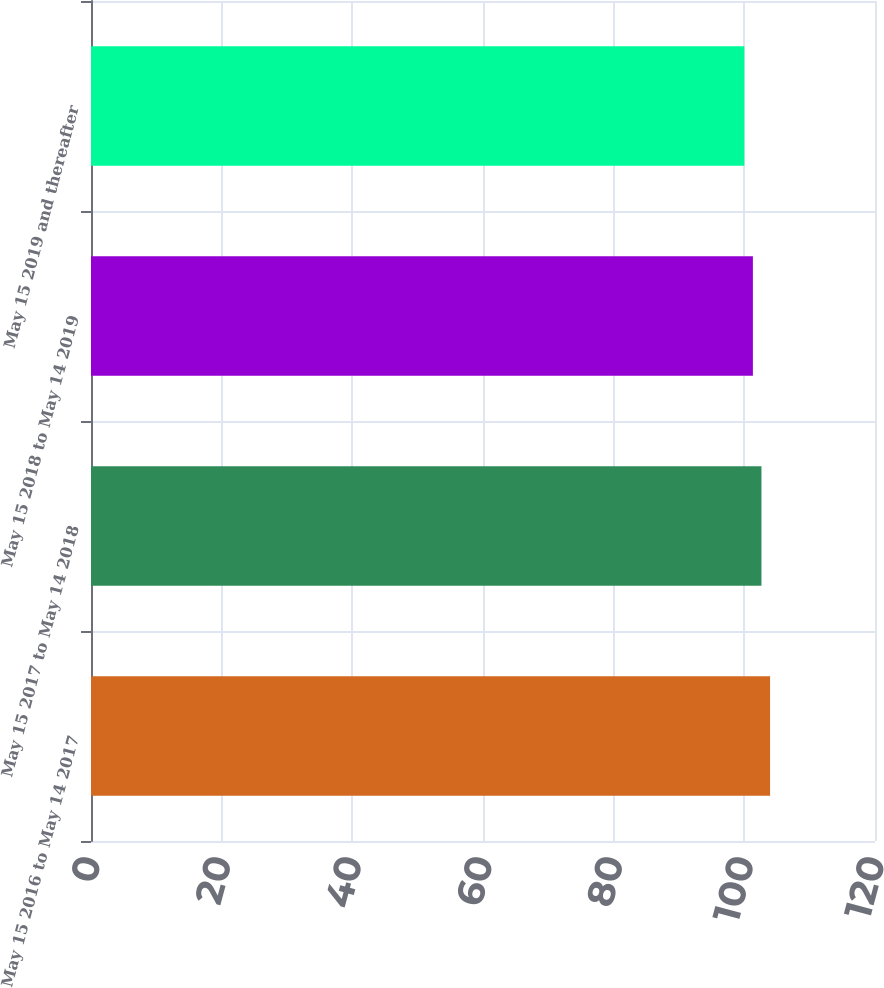Convert chart. <chart><loc_0><loc_0><loc_500><loc_500><bar_chart><fcel>May 15 2016 to May 14 2017<fcel>May 15 2017 to May 14 2018<fcel>May 15 2018 to May 14 2019<fcel>May 15 2019 and thereafter<nl><fcel>103.94<fcel>102.62<fcel>101.31<fcel>100<nl></chart> 